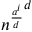Convert formula to latex. <formula><loc_0><loc_0><loc_500><loc_500>{ n ^ { \frac { a ^ { i } } { d } } } ^ { d }</formula> 